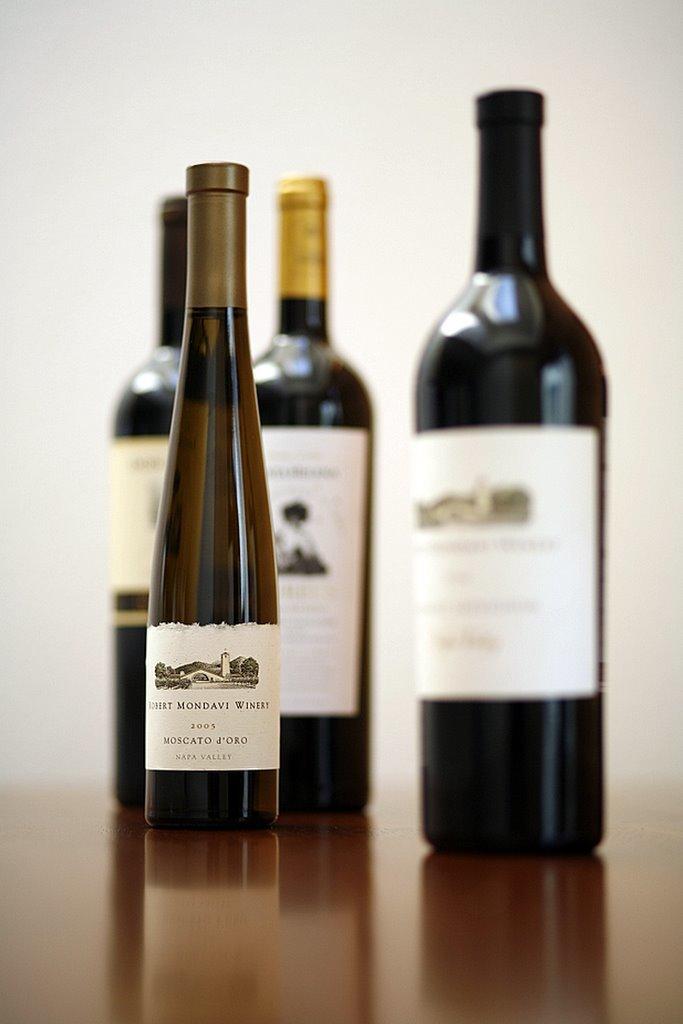The smallest bottle of wine is what brand?
Ensure brevity in your answer.  Robert mondavi. What year was the small bottle of wine produced?
Make the answer very short. 2005. 